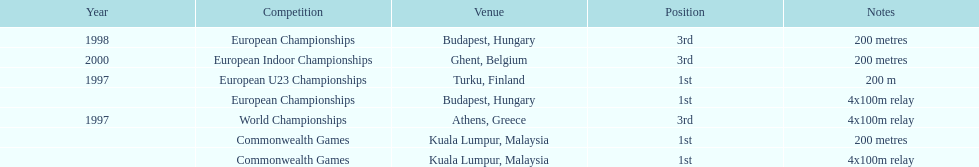List the other competitions besides european u23 championship that came in 1st position? European Championships, Commonwealth Games, Commonwealth Games. 